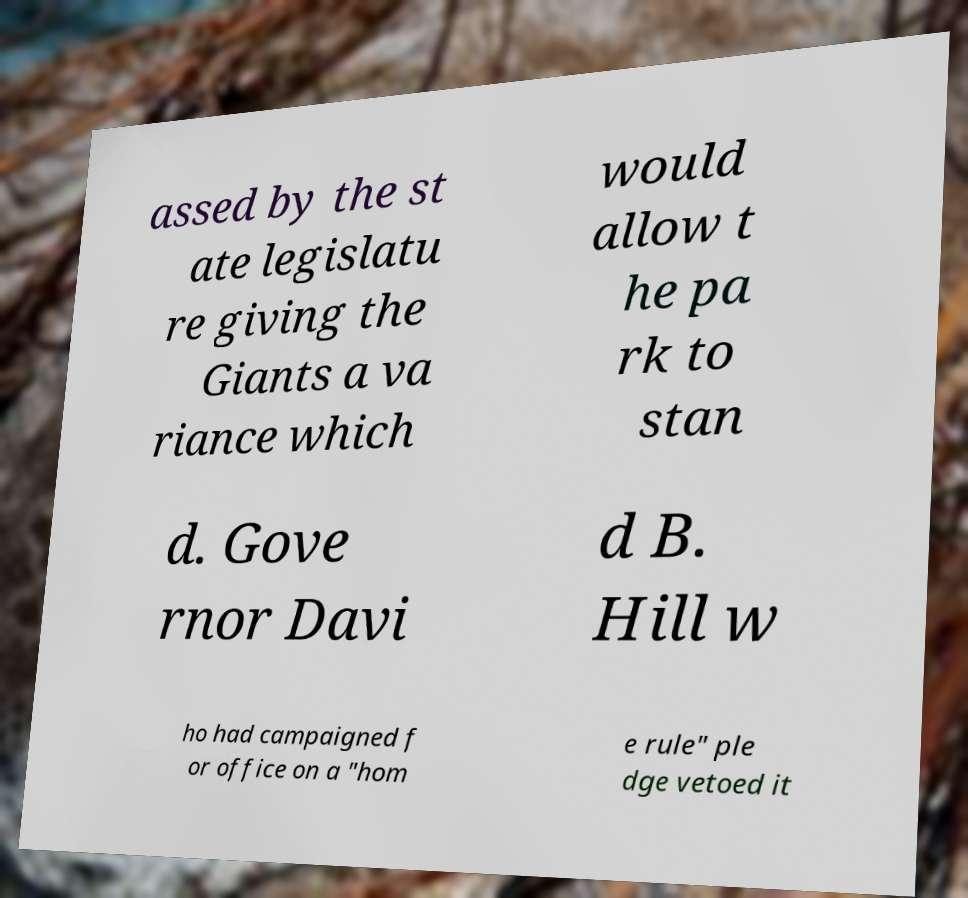Can you read and provide the text displayed in the image?This photo seems to have some interesting text. Can you extract and type it out for me? assed by the st ate legislatu re giving the Giants a va riance which would allow t he pa rk to stan d. Gove rnor Davi d B. Hill w ho had campaigned f or office on a "hom e rule" ple dge vetoed it 